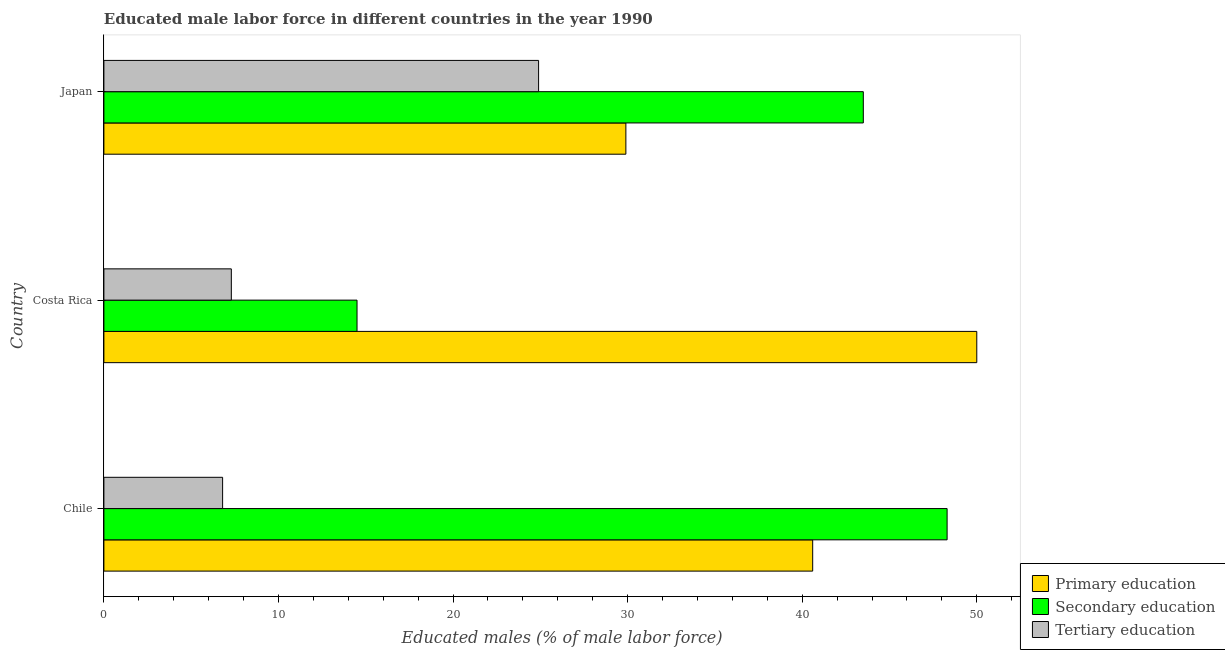How many different coloured bars are there?
Offer a very short reply. 3. How many groups of bars are there?
Your response must be concise. 3. Are the number of bars on each tick of the Y-axis equal?
Offer a very short reply. Yes. In how many cases, is the number of bars for a given country not equal to the number of legend labels?
Ensure brevity in your answer.  0. What is the percentage of male labor force who received secondary education in Chile?
Provide a short and direct response. 48.3. Across all countries, what is the maximum percentage of male labor force who received secondary education?
Make the answer very short. 48.3. Across all countries, what is the minimum percentage of male labor force who received primary education?
Make the answer very short. 29.9. What is the total percentage of male labor force who received tertiary education in the graph?
Your response must be concise. 39. What is the difference between the percentage of male labor force who received primary education in Costa Rica and the percentage of male labor force who received tertiary education in Japan?
Provide a succinct answer. 25.1. What is the average percentage of male labor force who received secondary education per country?
Your answer should be compact. 35.43. In how many countries, is the percentage of male labor force who received secondary education greater than 46 %?
Your answer should be compact. 1. What is the ratio of the percentage of male labor force who received primary education in Chile to that in Japan?
Give a very brief answer. 1.36. Is the percentage of male labor force who received tertiary education in Chile less than that in Costa Rica?
Your answer should be very brief. Yes. Is the difference between the percentage of male labor force who received tertiary education in Costa Rica and Japan greater than the difference between the percentage of male labor force who received primary education in Costa Rica and Japan?
Give a very brief answer. No. What is the difference between the highest and the second highest percentage of male labor force who received primary education?
Provide a short and direct response. 9.4. What is the difference between the highest and the lowest percentage of male labor force who received secondary education?
Provide a succinct answer. 33.8. Is the sum of the percentage of male labor force who received primary education in Costa Rica and Japan greater than the maximum percentage of male labor force who received tertiary education across all countries?
Give a very brief answer. Yes. What does the 2nd bar from the bottom in Chile represents?
Keep it short and to the point. Secondary education. Is it the case that in every country, the sum of the percentage of male labor force who received primary education and percentage of male labor force who received secondary education is greater than the percentage of male labor force who received tertiary education?
Provide a short and direct response. Yes. Are all the bars in the graph horizontal?
Keep it short and to the point. Yes. What is the difference between two consecutive major ticks on the X-axis?
Offer a terse response. 10. Does the graph contain any zero values?
Offer a very short reply. No. Where does the legend appear in the graph?
Your response must be concise. Bottom right. What is the title of the graph?
Your response must be concise. Educated male labor force in different countries in the year 1990. Does "Central government" appear as one of the legend labels in the graph?
Your answer should be very brief. No. What is the label or title of the X-axis?
Provide a short and direct response. Educated males (% of male labor force). What is the label or title of the Y-axis?
Provide a short and direct response. Country. What is the Educated males (% of male labor force) in Primary education in Chile?
Offer a terse response. 40.6. What is the Educated males (% of male labor force) of Secondary education in Chile?
Your response must be concise. 48.3. What is the Educated males (% of male labor force) in Tertiary education in Chile?
Your answer should be very brief. 6.8. What is the Educated males (% of male labor force) of Tertiary education in Costa Rica?
Keep it short and to the point. 7.3. What is the Educated males (% of male labor force) in Primary education in Japan?
Keep it short and to the point. 29.9. What is the Educated males (% of male labor force) of Secondary education in Japan?
Your answer should be compact. 43.5. What is the Educated males (% of male labor force) in Tertiary education in Japan?
Your response must be concise. 24.9. Across all countries, what is the maximum Educated males (% of male labor force) in Primary education?
Provide a succinct answer. 50. Across all countries, what is the maximum Educated males (% of male labor force) of Secondary education?
Your answer should be compact. 48.3. Across all countries, what is the maximum Educated males (% of male labor force) of Tertiary education?
Provide a short and direct response. 24.9. Across all countries, what is the minimum Educated males (% of male labor force) of Primary education?
Your response must be concise. 29.9. Across all countries, what is the minimum Educated males (% of male labor force) of Tertiary education?
Your answer should be compact. 6.8. What is the total Educated males (% of male labor force) of Primary education in the graph?
Provide a short and direct response. 120.5. What is the total Educated males (% of male labor force) in Secondary education in the graph?
Make the answer very short. 106.3. What is the total Educated males (% of male labor force) of Tertiary education in the graph?
Your answer should be very brief. 39. What is the difference between the Educated males (% of male labor force) in Secondary education in Chile and that in Costa Rica?
Keep it short and to the point. 33.8. What is the difference between the Educated males (% of male labor force) in Tertiary education in Chile and that in Japan?
Offer a terse response. -18.1. What is the difference between the Educated males (% of male labor force) of Primary education in Costa Rica and that in Japan?
Offer a very short reply. 20.1. What is the difference between the Educated males (% of male labor force) of Tertiary education in Costa Rica and that in Japan?
Provide a short and direct response. -17.6. What is the difference between the Educated males (% of male labor force) of Primary education in Chile and the Educated males (% of male labor force) of Secondary education in Costa Rica?
Provide a succinct answer. 26.1. What is the difference between the Educated males (% of male labor force) in Primary education in Chile and the Educated males (% of male labor force) in Tertiary education in Costa Rica?
Offer a terse response. 33.3. What is the difference between the Educated males (% of male labor force) in Primary education in Chile and the Educated males (% of male labor force) in Tertiary education in Japan?
Provide a succinct answer. 15.7. What is the difference between the Educated males (% of male labor force) of Secondary education in Chile and the Educated males (% of male labor force) of Tertiary education in Japan?
Provide a succinct answer. 23.4. What is the difference between the Educated males (% of male labor force) of Primary education in Costa Rica and the Educated males (% of male labor force) of Tertiary education in Japan?
Ensure brevity in your answer.  25.1. What is the difference between the Educated males (% of male labor force) in Secondary education in Costa Rica and the Educated males (% of male labor force) in Tertiary education in Japan?
Your answer should be compact. -10.4. What is the average Educated males (% of male labor force) in Primary education per country?
Keep it short and to the point. 40.17. What is the average Educated males (% of male labor force) in Secondary education per country?
Your answer should be very brief. 35.43. What is the average Educated males (% of male labor force) in Tertiary education per country?
Make the answer very short. 13. What is the difference between the Educated males (% of male labor force) in Primary education and Educated males (% of male labor force) in Secondary education in Chile?
Your response must be concise. -7.7. What is the difference between the Educated males (% of male labor force) in Primary education and Educated males (% of male labor force) in Tertiary education in Chile?
Offer a terse response. 33.8. What is the difference between the Educated males (% of male labor force) in Secondary education and Educated males (% of male labor force) in Tertiary education in Chile?
Make the answer very short. 41.5. What is the difference between the Educated males (% of male labor force) of Primary education and Educated males (% of male labor force) of Secondary education in Costa Rica?
Make the answer very short. 35.5. What is the difference between the Educated males (% of male labor force) in Primary education and Educated males (% of male labor force) in Tertiary education in Costa Rica?
Provide a short and direct response. 42.7. What is the difference between the Educated males (% of male labor force) in Secondary education and Educated males (% of male labor force) in Tertiary education in Costa Rica?
Your answer should be very brief. 7.2. What is the difference between the Educated males (% of male labor force) in Primary education and Educated males (% of male labor force) in Secondary education in Japan?
Your response must be concise. -13.6. What is the difference between the Educated males (% of male labor force) in Secondary education and Educated males (% of male labor force) in Tertiary education in Japan?
Your response must be concise. 18.6. What is the ratio of the Educated males (% of male labor force) of Primary education in Chile to that in Costa Rica?
Provide a succinct answer. 0.81. What is the ratio of the Educated males (% of male labor force) in Secondary education in Chile to that in Costa Rica?
Your response must be concise. 3.33. What is the ratio of the Educated males (% of male labor force) in Tertiary education in Chile to that in Costa Rica?
Give a very brief answer. 0.93. What is the ratio of the Educated males (% of male labor force) of Primary education in Chile to that in Japan?
Your response must be concise. 1.36. What is the ratio of the Educated males (% of male labor force) in Secondary education in Chile to that in Japan?
Give a very brief answer. 1.11. What is the ratio of the Educated males (% of male labor force) in Tertiary education in Chile to that in Japan?
Provide a short and direct response. 0.27. What is the ratio of the Educated males (% of male labor force) in Primary education in Costa Rica to that in Japan?
Offer a very short reply. 1.67. What is the ratio of the Educated males (% of male labor force) of Secondary education in Costa Rica to that in Japan?
Make the answer very short. 0.33. What is the ratio of the Educated males (% of male labor force) in Tertiary education in Costa Rica to that in Japan?
Ensure brevity in your answer.  0.29. What is the difference between the highest and the second highest Educated males (% of male labor force) of Primary education?
Offer a very short reply. 9.4. What is the difference between the highest and the second highest Educated males (% of male labor force) in Secondary education?
Provide a short and direct response. 4.8. What is the difference between the highest and the lowest Educated males (% of male labor force) of Primary education?
Your answer should be very brief. 20.1. What is the difference between the highest and the lowest Educated males (% of male labor force) of Secondary education?
Your answer should be compact. 33.8. What is the difference between the highest and the lowest Educated males (% of male labor force) in Tertiary education?
Your answer should be compact. 18.1. 